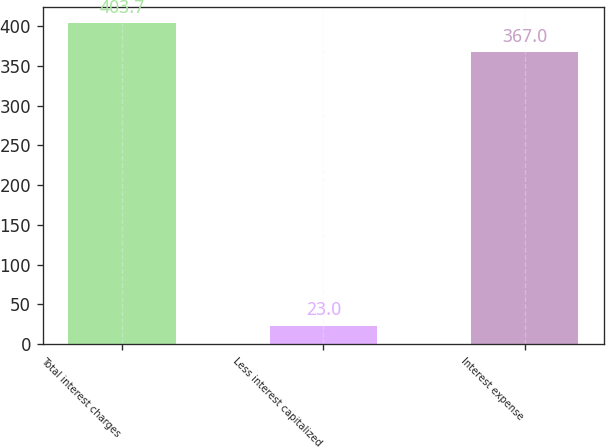<chart> <loc_0><loc_0><loc_500><loc_500><bar_chart><fcel>Total interest charges<fcel>Less interest capitalized<fcel>Interest expense<nl><fcel>403.7<fcel>23<fcel>367<nl></chart> 